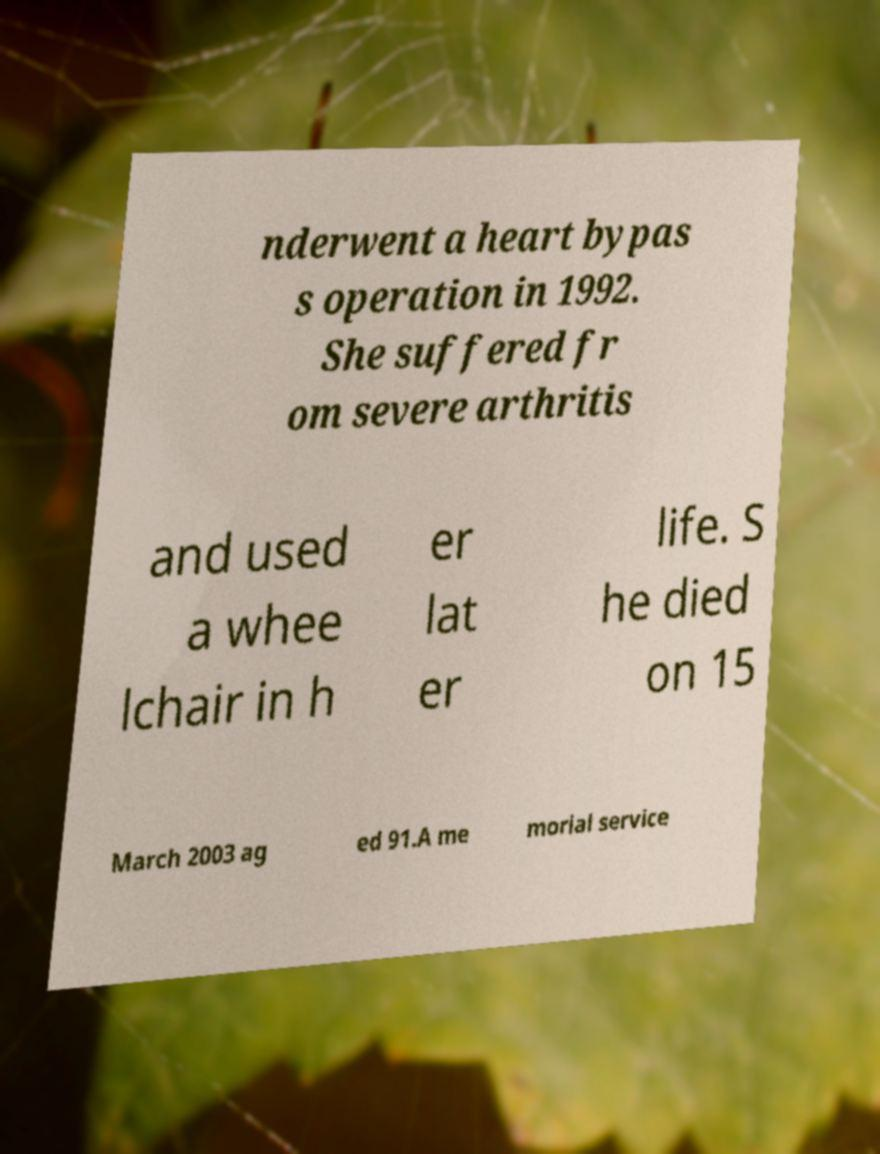Please identify and transcribe the text found in this image. nderwent a heart bypas s operation in 1992. She suffered fr om severe arthritis and used a whee lchair in h er lat er life. S he died on 15 March 2003 ag ed 91.A me morial service 